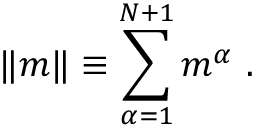Convert formula to latex. <formula><loc_0><loc_0><loc_500><loc_500>\| m \| \equiv \sum _ { \alpha = 1 } ^ { N + 1 } m ^ { \alpha } \ .</formula> 